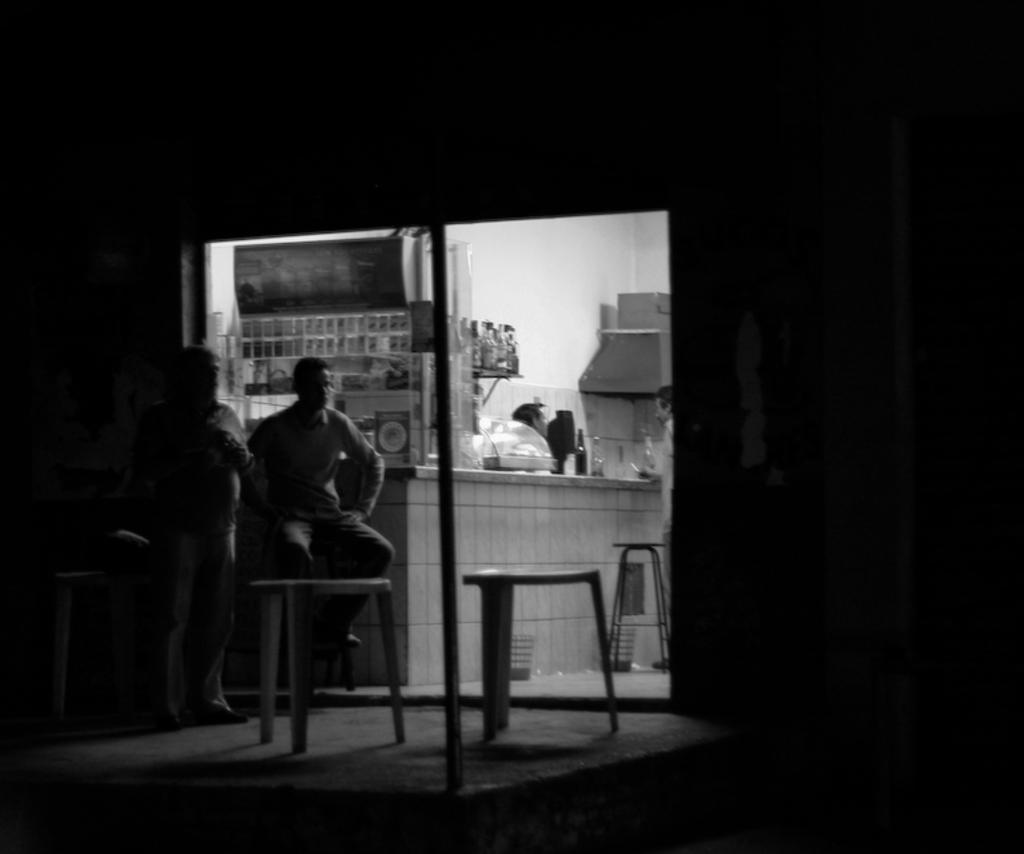Could you give a brief overview of what you see in this image? This is a black and white image and here we can see people and one of them is sitting on the stand and there are some stools. In the background, there are bottles and some other objects and we can see a pole and a wall. At the bottom, there is a floor. 